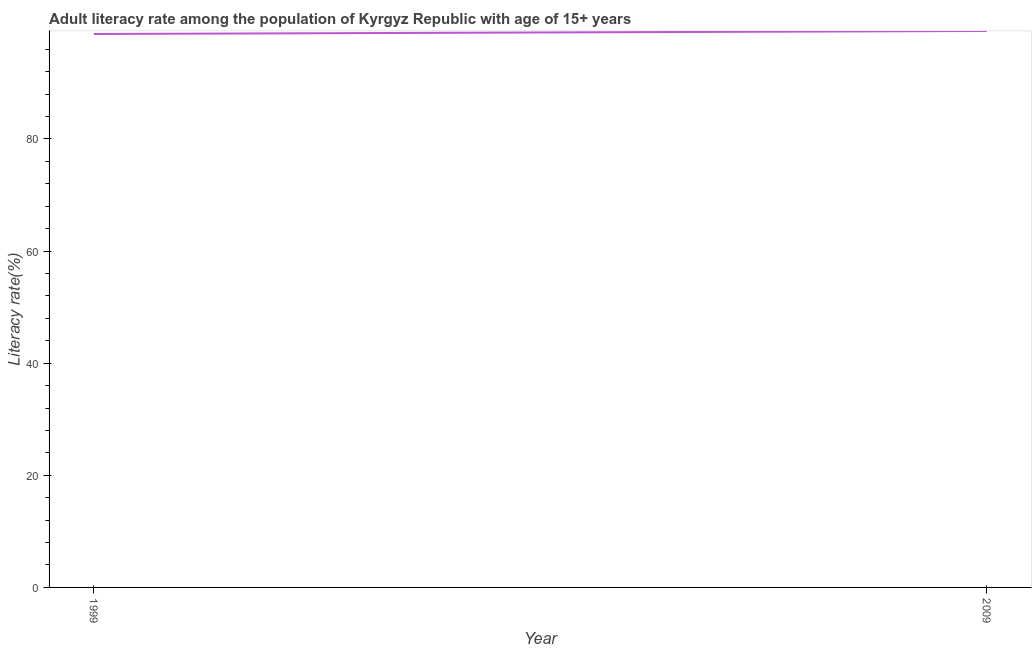What is the adult literacy rate in 2009?
Give a very brief answer. 99.24. Across all years, what is the maximum adult literacy rate?
Offer a very short reply. 99.24. Across all years, what is the minimum adult literacy rate?
Ensure brevity in your answer.  98.7. In which year was the adult literacy rate maximum?
Provide a succinct answer. 2009. In which year was the adult literacy rate minimum?
Ensure brevity in your answer.  1999. What is the sum of the adult literacy rate?
Your response must be concise. 197.94. What is the difference between the adult literacy rate in 1999 and 2009?
Offer a terse response. -0.54. What is the average adult literacy rate per year?
Ensure brevity in your answer.  98.97. What is the median adult literacy rate?
Give a very brief answer. 98.97. In how many years, is the adult literacy rate greater than 72 %?
Your response must be concise. 2. Do a majority of the years between 2009 and 1999 (inclusive) have adult literacy rate greater than 48 %?
Your answer should be compact. No. What is the ratio of the adult literacy rate in 1999 to that in 2009?
Your response must be concise. 0.99. Is the adult literacy rate in 1999 less than that in 2009?
Your response must be concise. Yes. In how many years, is the adult literacy rate greater than the average adult literacy rate taken over all years?
Ensure brevity in your answer.  1. How many lines are there?
Offer a terse response. 1. How many years are there in the graph?
Give a very brief answer. 2. What is the title of the graph?
Provide a succinct answer. Adult literacy rate among the population of Kyrgyz Republic with age of 15+ years. What is the label or title of the X-axis?
Make the answer very short. Year. What is the label or title of the Y-axis?
Ensure brevity in your answer.  Literacy rate(%). What is the Literacy rate(%) in 1999?
Keep it short and to the point. 98.7. What is the Literacy rate(%) in 2009?
Your answer should be compact. 99.24. What is the difference between the Literacy rate(%) in 1999 and 2009?
Your answer should be very brief. -0.54. 